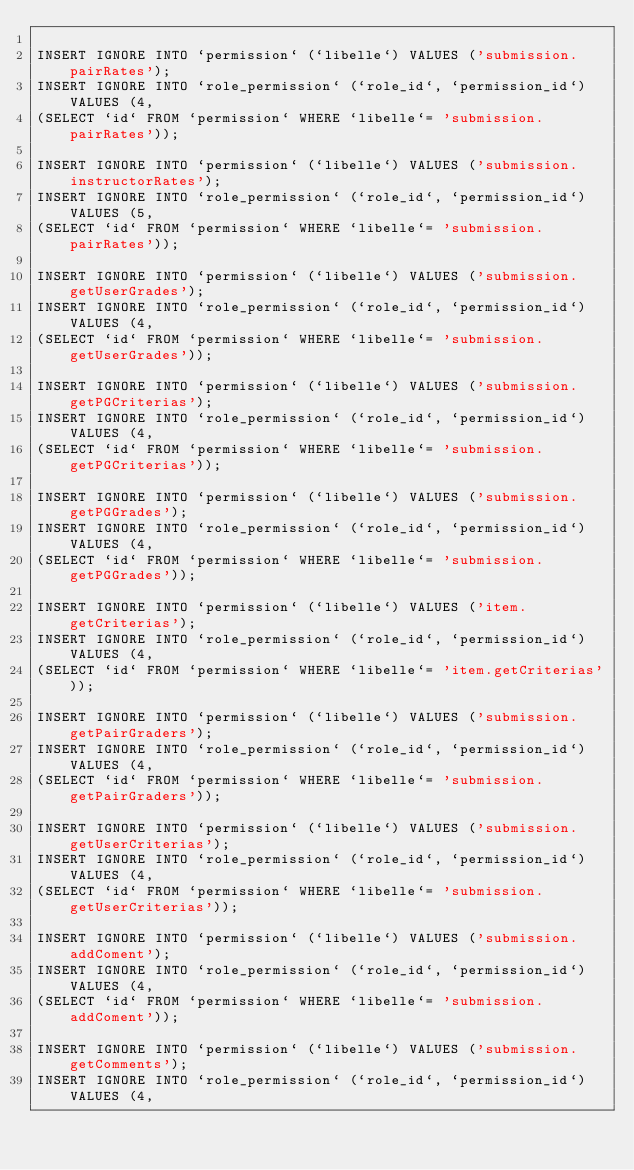Convert code to text. <code><loc_0><loc_0><loc_500><loc_500><_SQL_>
INSERT IGNORE INTO `permission` (`libelle`) VALUES ('submission.pairRates');
INSERT IGNORE INTO `role_permission` (`role_id`, `permission_id`) VALUES (4, 
(SELECT `id` FROM `permission` WHERE `libelle`= 'submission.pairRates'));

INSERT IGNORE INTO `permission` (`libelle`) VALUES ('submission.instructorRates');
INSERT IGNORE INTO `role_permission` (`role_id`, `permission_id`) VALUES (5, 
(SELECT `id` FROM `permission` WHERE `libelle`= 'submission.pairRates'));

INSERT IGNORE INTO `permission` (`libelle`) VALUES ('submission.getUserGrades');
INSERT IGNORE INTO `role_permission` (`role_id`, `permission_id`) VALUES (4, 
(SELECT `id` FROM `permission` WHERE `libelle`= 'submission.getUserGrades'));

INSERT IGNORE INTO `permission` (`libelle`) VALUES ('submission.getPGCriterias');
INSERT IGNORE INTO `role_permission` (`role_id`, `permission_id`) VALUES (4, 
(SELECT `id` FROM `permission` WHERE `libelle`= 'submission.getPGCriterias'));

INSERT IGNORE INTO `permission` (`libelle`) VALUES ('submission.getPGGrades');
INSERT IGNORE INTO `role_permission` (`role_id`, `permission_id`) VALUES (4, 
(SELECT `id` FROM `permission` WHERE `libelle`= 'submission.getPGGrades'));

INSERT IGNORE INTO `permission` (`libelle`) VALUES ('item.getCriterias');
INSERT IGNORE INTO `role_permission` (`role_id`, `permission_id`) VALUES (4, 
(SELECT `id` FROM `permission` WHERE `libelle`= 'item.getCriterias'));

INSERT IGNORE INTO `permission` (`libelle`) VALUES ('submission.getPairGraders');
INSERT IGNORE INTO `role_permission` (`role_id`, `permission_id`) VALUES (4, 
(SELECT `id` FROM `permission` WHERE `libelle`= 'submission.getPairGraders'));

INSERT IGNORE INTO `permission` (`libelle`) VALUES ('submission.getUserCriterias');
INSERT IGNORE INTO `role_permission` (`role_id`, `permission_id`) VALUES (4, 
(SELECT `id` FROM `permission` WHERE `libelle`= 'submission.getUserCriterias'));

INSERT IGNORE INTO `permission` (`libelle`) VALUES ('submission.addComent');
INSERT IGNORE INTO `role_permission` (`role_id`, `permission_id`) VALUES (4, 
(SELECT `id` FROM `permission` WHERE `libelle`= 'submission.addComent'));

INSERT IGNORE INTO `permission` (`libelle`) VALUES ('submission.getComments');
INSERT IGNORE INTO `role_permission` (`role_id`, `permission_id`) VALUES (4, </code> 